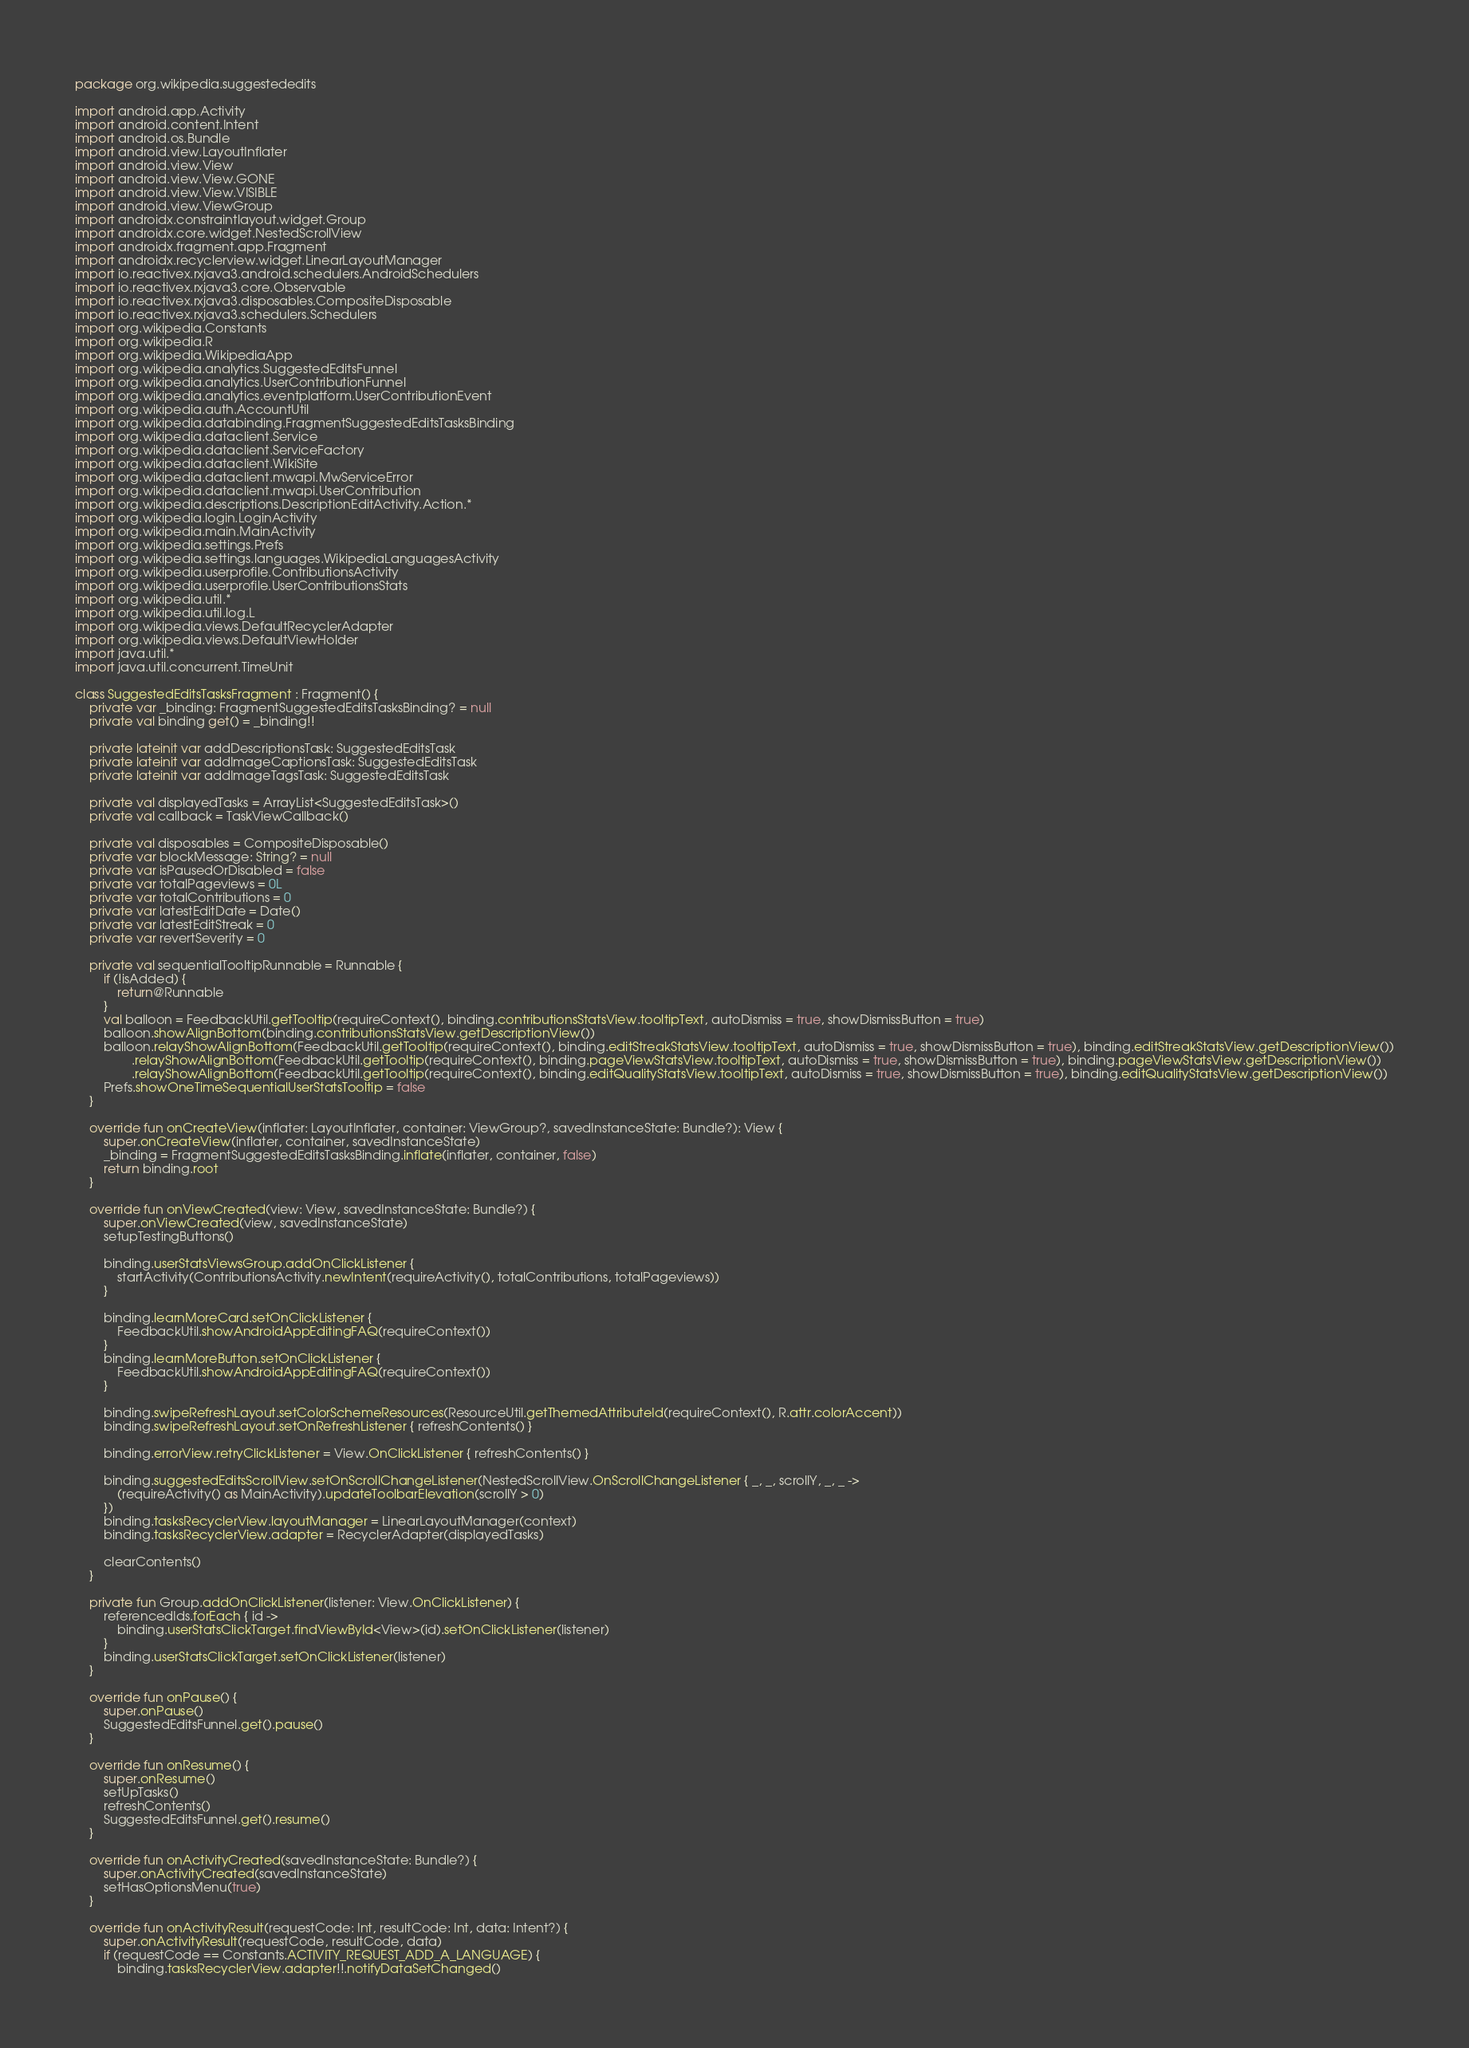<code> <loc_0><loc_0><loc_500><loc_500><_Kotlin_>package org.wikipedia.suggestededits

import android.app.Activity
import android.content.Intent
import android.os.Bundle
import android.view.LayoutInflater
import android.view.View
import android.view.View.GONE
import android.view.View.VISIBLE
import android.view.ViewGroup
import androidx.constraintlayout.widget.Group
import androidx.core.widget.NestedScrollView
import androidx.fragment.app.Fragment
import androidx.recyclerview.widget.LinearLayoutManager
import io.reactivex.rxjava3.android.schedulers.AndroidSchedulers
import io.reactivex.rxjava3.core.Observable
import io.reactivex.rxjava3.disposables.CompositeDisposable
import io.reactivex.rxjava3.schedulers.Schedulers
import org.wikipedia.Constants
import org.wikipedia.R
import org.wikipedia.WikipediaApp
import org.wikipedia.analytics.SuggestedEditsFunnel
import org.wikipedia.analytics.UserContributionFunnel
import org.wikipedia.analytics.eventplatform.UserContributionEvent
import org.wikipedia.auth.AccountUtil
import org.wikipedia.databinding.FragmentSuggestedEditsTasksBinding
import org.wikipedia.dataclient.Service
import org.wikipedia.dataclient.ServiceFactory
import org.wikipedia.dataclient.WikiSite
import org.wikipedia.dataclient.mwapi.MwServiceError
import org.wikipedia.dataclient.mwapi.UserContribution
import org.wikipedia.descriptions.DescriptionEditActivity.Action.*
import org.wikipedia.login.LoginActivity
import org.wikipedia.main.MainActivity
import org.wikipedia.settings.Prefs
import org.wikipedia.settings.languages.WikipediaLanguagesActivity
import org.wikipedia.userprofile.ContributionsActivity
import org.wikipedia.userprofile.UserContributionsStats
import org.wikipedia.util.*
import org.wikipedia.util.log.L
import org.wikipedia.views.DefaultRecyclerAdapter
import org.wikipedia.views.DefaultViewHolder
import java.util.*
import java.util.concurrent.TimeUnit

class SuggestedEditsTasksFragment : Fragment() {
    private var _binding: FragmentSuggestedEditsTasksBinding? = null
    private val binding get() = _binding!!

    private lateinit var addDescriptionsTask: SuggestedEditsTask
    private lateinit var addImageCaptionsTask: SuggestedEditsTask
    private lateinit var addImageTagsTask: SuggestedEditsTask

    private val displayedTasks = ArrayList<SuggestedEditsTask>()
    private val callback = TaskViewCallback()

    private val disposables = CompositeDisposable()
    private var blockMessage: String? = null
    private var isPausedOrDisabled = false
    private var totalPageviews = 0L
    private var totalContributions = 0
    private var latestEditDate = Date()
    private var latestEditStreak = 0
    private var revertSeverity = 0

    private val sequentialTooltipRunnable = Runnable {
        if (!isAdded) {
            return@Runnable
        }
        val balloon = FeedbackUtil.getTooltip(requireContext(), binding.contributionsStatsView.tooltipText, autoDismiss = true, showDismissButton = true)
        balloon.showAlignBottom(binding.contributionsStatsView.getDescriptionView())
        balloon.relayShowAlignBottom(FeedbackUtil.getTooltip(requireContext(), binding.editStreakStatsView.tooltipText, autoDismiss = true, showDismissButton = true), binding.editStreakStatsView.getDescriptionView())
                .relayShowAlignBottom(FeedbackUtil.getTooltip(requireContext(), binding.pageViewStatsView.tooltipText, autoDismiss = true, showDismissButton = true), binding.pageViewStatsView.getDescriptionView())
                .relayShowAlignBottom(FeedbackUtil.getTooltip(requireContext(), binding.editQualityStatsView.tooltipText, autoDismiss = true, showDismissButton = true), binding.editQualityStatsView.getDescriptionView())
        Prefs.showOneTimeSequentialUserStatsTooltip = false
    }

    override fun onCreateView(inflater: LayoutInflater, container: ViewGroup?, savedInstanceState: Bundle?): View {
        super.onCreateView(inflater, container, savedInstanceState)
        _binding = FragmentSuggestedEditsTasksBinding.inflate(inflater, container, false)
        return binding.root
    }

    override fun onViewCreated(view: View, savedInstanceState: Bundle?) {
        super.onViewCreated(view, savedInstanceState)
        setupTestingButtons()

        binding.userStatsViewsGroup.addOnClickListener {
            startActivity(ContributionsActivity.newIntent(requireActivity(), totalContributions, totalPageviews))
        }

        binding.learnMoreCard.setOnClickListener {
            FeedbackUtil.showAndroidAppEditingFAQ(requireContext())
        }
        binding.learnMoreButton.setOnClickListener {
            FeedbackUtil.showAndroidAppEditingFAQ(requireContext())
        }

        binding.swipeRefreshLayout.setColorSchemeResources(ResourceUtil.getThemedAttributeId(requireContext(), R.attr.colorAccent))
        binding.swipeRefreshLayout.setOnRefreshListener { refreshContents() }

        binding.errorView.retryClickListener = View.OnClickListener { refreshContents() }

        binding.suggestedEditsScrollView.setOnScrollChangeListener(NestedScrollView.OnScrollChangeListener { _, _, scrollY, _, _ ->
            (requireActivity() as MainActivity).updateToolbarElevation(scrollY > 0)
        })
        binding.tasksRecyclerView.layoutManager = LinearLayoutManager(context)
        binding.tasksRecyclerView.adapter = RecyclerAdapter(displayedTasks)

        clearContents()
    }

    private fun Group.addOnClickListener(listener: View.OnClickListener) {
        referencedIds.forEach { id ->
            binding.userStatsClickTarget.findViewById<View>(id).setOnClickListener(listener)
        }
        binding.userStatsClickTarget.setOnClickListener(listener)
    }

    override fun onPause() {
        super.onPause()
        SuggestedEditsFunnel.get().pause()
    }

    override fun onResume() {
        super.onResume()
        setUpTasks()
        refreshContents()
        SuggestedEditsFunnel.get().resume()
    }

    override fun onActivityCreated(savedInstanceState: Bundle?) {
        super.onActivityCreated(savedInstanceState)
        setHasOptionsMenu(true)
    }

    override fun onActivityResult(requestCode: Int, resultCode: Int, data: Intent?) {
        super.onActivityResult(requestCode, resultCode, data)
        if (requestCode == Constants.ACTIVITY_REQUEST_ADD_A_LANGUAGE) {
            binding.tasksRecyclerView.adapter!!.notifyDataSetChanged()</code> 